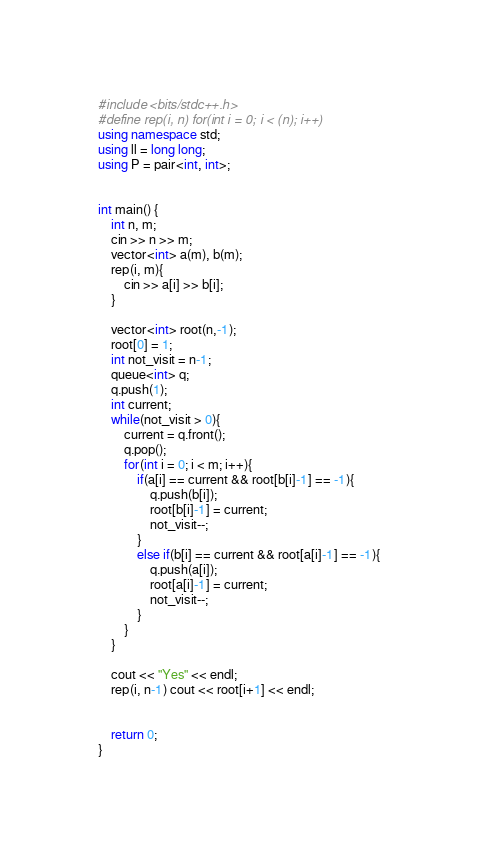Convert code to text. <code><loc_0><loc_0><loc_500><loc_500><_C++_>#include <bits/stdc++.h>
#define rep(i, n) for(int i = 0; i < (n); i++)
using namespace std;
using ll = long long;
using P = pair<int, int>;


int main() {
    int n, m;
    cin >> n >> m;
    vector<int> a(m), b(m);
    rep(i, m){
        cin >> a[i] >> b[i];
    }

    vector<int> root(n,-1);
    root[0] = 1;
    int not_visit = n-1;
    queue<int> q;
    q.push(1);
    int current;
    while(not_visit > 0){
        current = q.front();
        q.pop();
        for(int i = 0; i < m; i++){
            if(a[i] == current && root[b[i]-1] == -1){
                q.push(b[i]);
                root[b[i]-1] = current;
                not_visit--;
            }
            else if(b[i] == current && root[a[i]-1] == -1){
                q.push(a[i]);
                root[a[i]-1] = current;
                not_visit--;
            }
        }
    }

    cout << "Yes" << endl;
    rep(i, n-1) cout << root[i+1] << endl;


    return 0;
}</code> 